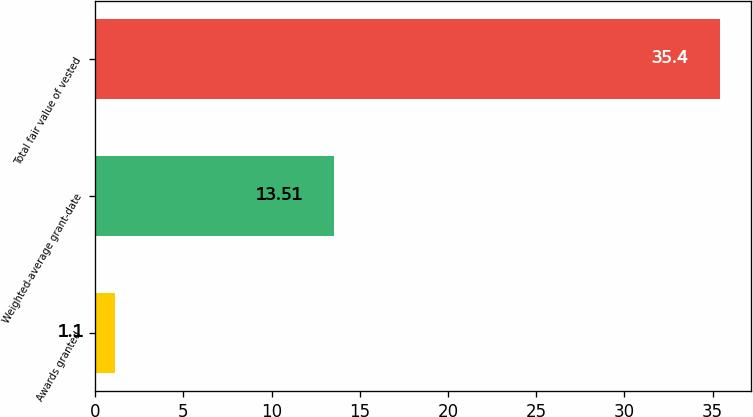Convert chart to OTSL. <chart><loc_0><loc_0><loc_500><loc_500><bar_chart><fcel>Awards granted<fcel>Weighted-average grant-date<fcel>Total fair value of vested<nl><fcel>1.1<fcel>13.51<fcel>35.4<nl></chart> 